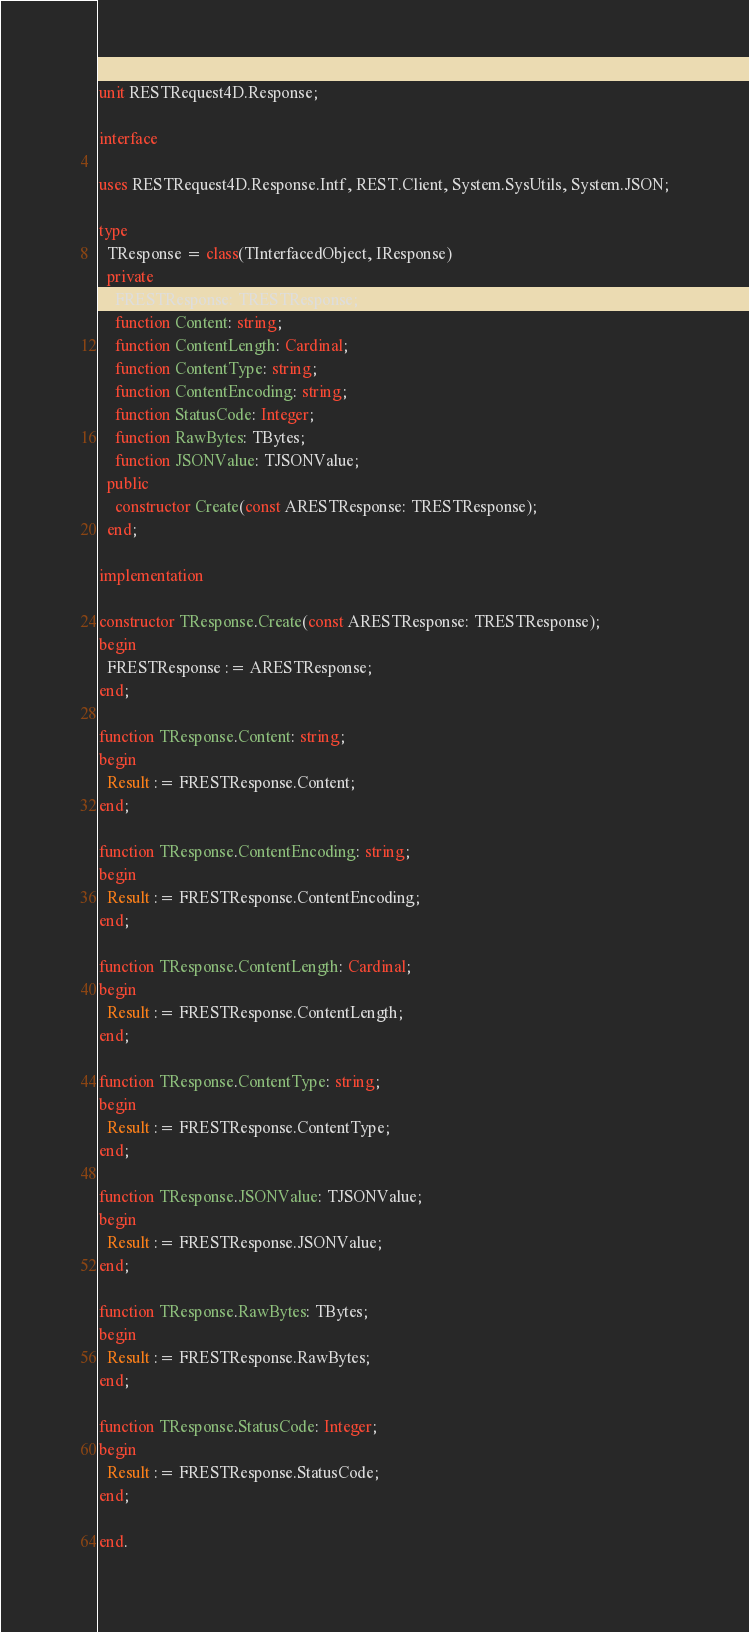Convert code to text. <code><loc_0><loc_0><loc_500><loc_500><_Pascal_>unit RESTRequest4D.Response;

interface

uses RESTRequest4D.Response.Intf, REST.Client, System.SysUtils, System.JSON;

type
  TResponse = class(TInterfacedObject, IResponse)
  private
    FRESTResponse: TRESTResponse;
    function Content: string;
    function ContentLength: Cardinal;
    function ContentType: string;
    function ContentEncoding: string;
    function StatusCode: Integer;
    function RawBytes: TBytes;
    function JSONValue: TJSONValue;
  public
    constructor Create(const ARESTResponse: TRESTResponse);
  end;

implementation

constructor TResponse.Create(const ARESTResponse: TRESTResponse);
begin
  FRESTResponse := ARESTResponse;
end;

function TResponse.Content: string;
begin
  Result := FRESTResponse.Content;
end;

function TResponse.ContentEncoding: string;
begin
  Result := FRESTResponse.ContentEncoding;
end;

function TResponse.ContentLength: Cardinal;
begin
  Result := FRESTResponse.ContentLength;
end;

function TResponse.ContentType: string;
begin
  Result := FRESTResponse.ContentType;
end;

function TResponse.JSONValue: TJSONValue;
begin
  Result := FRESTResponse.JSONValue;
end;

function TResponse.RawBytes: TBytes;
begin
  Result := FRESTResponse.RawBytes;
end;        

function TResponse.StatusCode: Integer;
begin
  Result := FRESTResponse.StatusCode;
end;

end.
</code> 